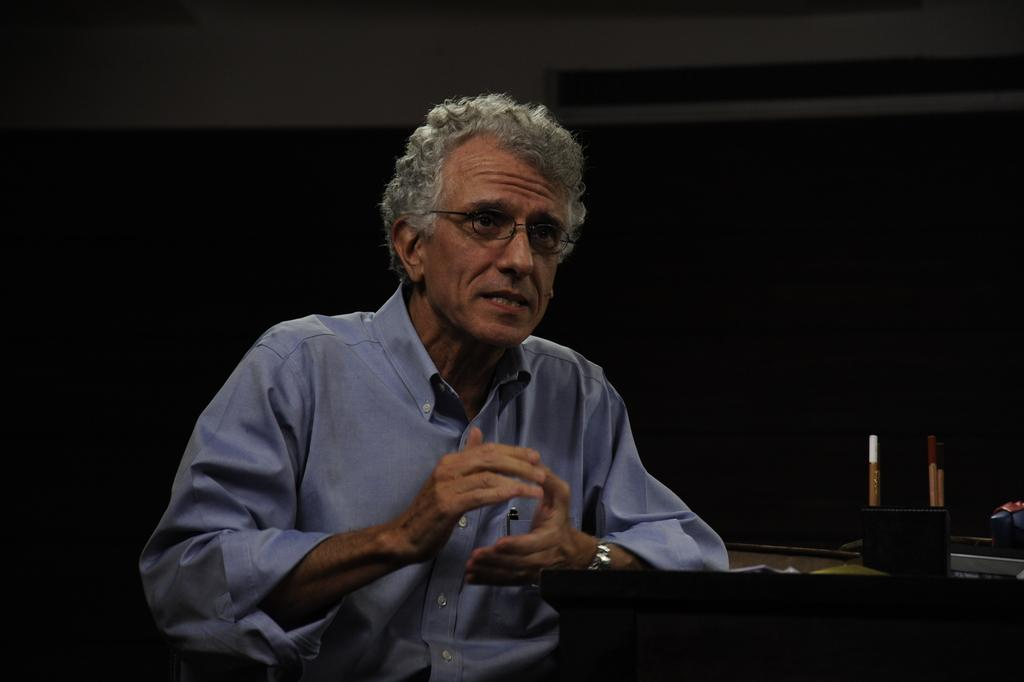What is the man in the image doing? The man is sitting in the image. What object can be seen on the table in the image? There is a pen stand on the table in the image. How would you describe the lighting in the image? The background of the image is dark. What type of pleasure can be seen in the image? There is no indication of pleasure in the image; it simply shows a man sitting and a pen stand on the table. 